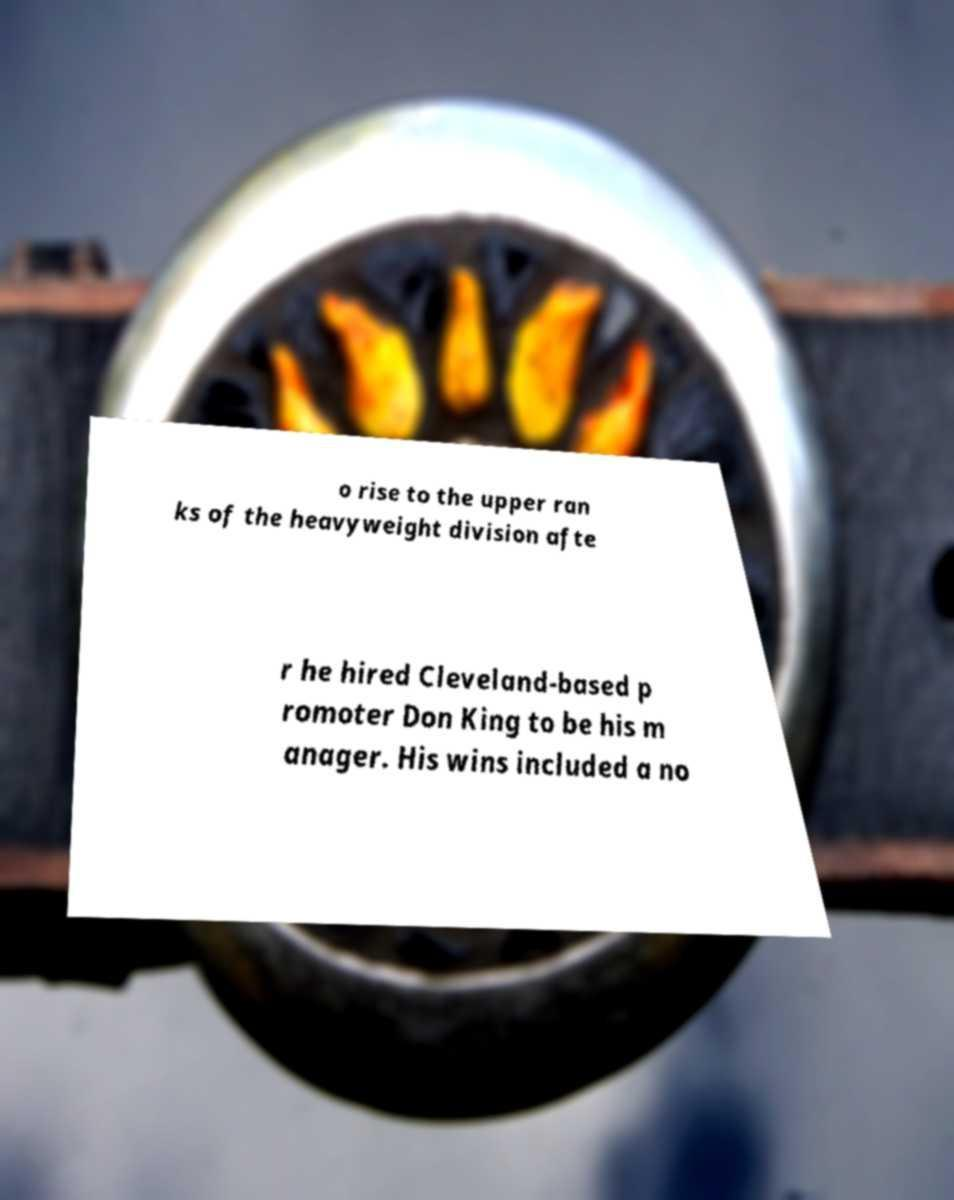Could you assist in decoding the text presented in this image and type it out clearly? o rise to the upper ran ks of the heavyweight division afte r he hired Cleveland-based p romoter Don King to be his m anager. His wins included a no 